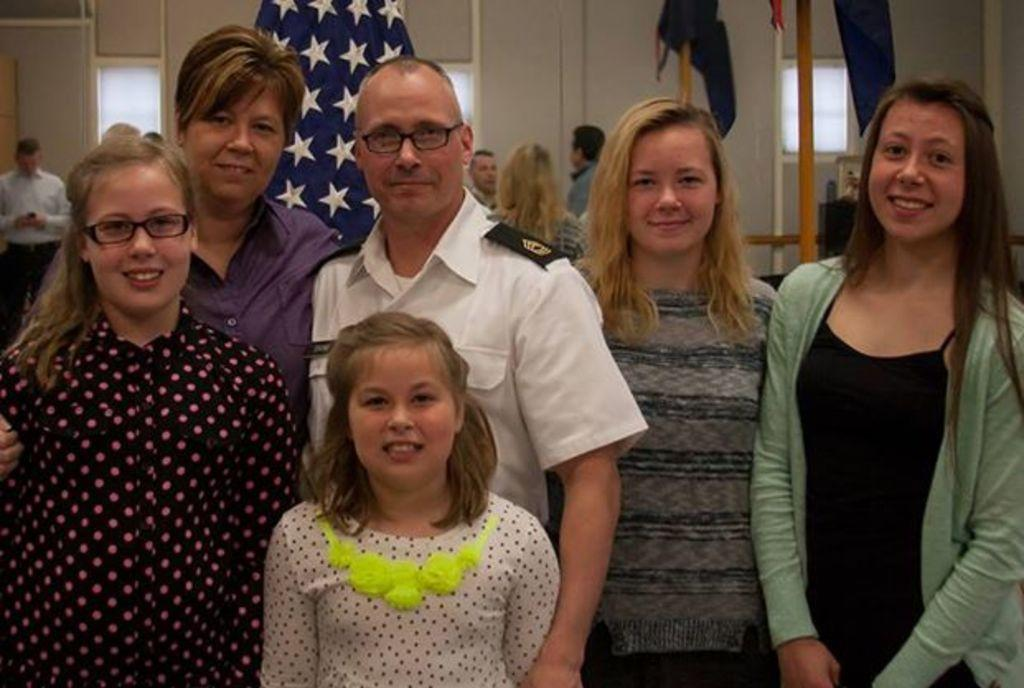Who or what is present in the image? There are people in the image. What is the facial expression of the people in the image? The people in the image are smiling. What can be seen in the background of the image? There are flags, poles, and a wall in the background of the image. Are there more people in the background of the image? Yes, there are more people in the background of the image. What type of brass instrument is being played by the people in the image? There is no brass instrument visible in the image; the people are simply smiling. Can you see any fog in the image? No, there is no fog present in the image. 